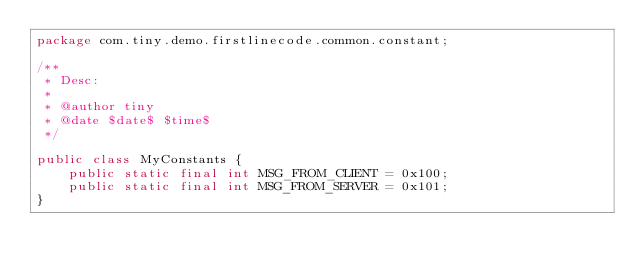<code> <loc_0><loc_0><loc_500><loc_500><_Java_>package com.tiny.demo.firstlinecode.common.constant;

/**
 * Desc:
 *
 * @author tiny
 * @date $date$ $time$
 */

public class MyConstants {
    public static final int MSG_FROM_CLIENT = 0x100;
    public static final int MSG_FROM_SERVER = 0x101;
}
</code> 